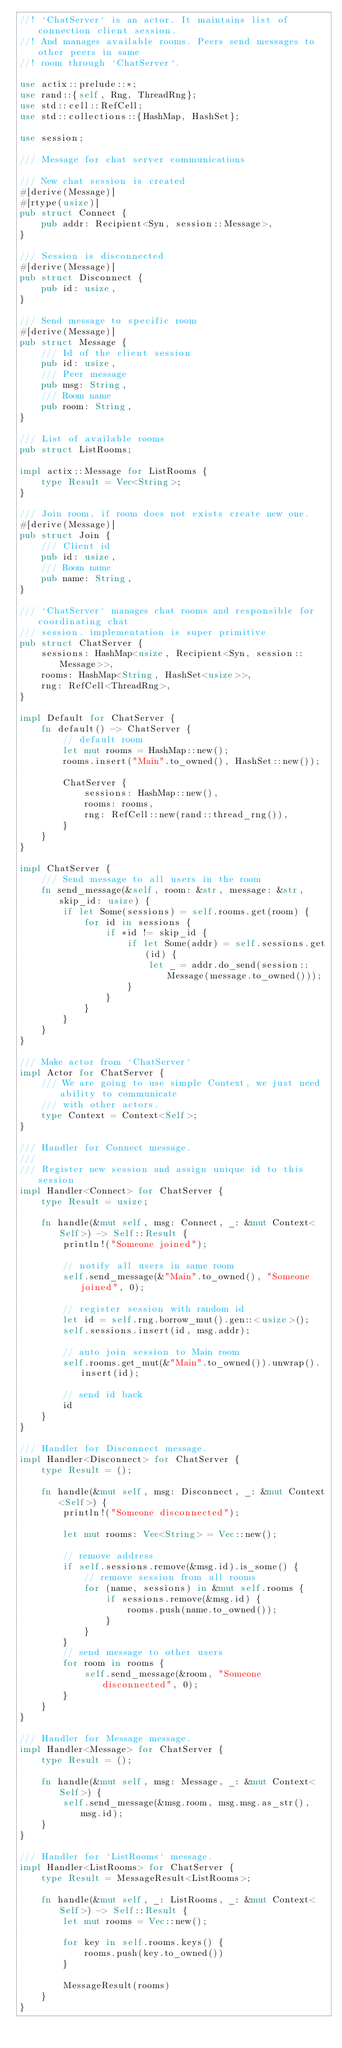<code> <loc_0><loc_0><loc_500><loc_500><_Rust_>//! `ChatServer` is an actor. It maintains list of connection client session.
//! And manages available rooms. Peers send messages to other peers in same
//! room through `ChatServer`.

use actix::prelude::*;
use rand::{self, Rng, ThreadRng};
use std::cell::RefCell;
use std::collections::{HashMap, HashSet};

use session;

/// Message for chat server communications

/// New chat session is created
#[derive(Message)]
#[rtype(usize)]
pub struct Connect {
    pub addr: Recipient<Syn, session::Message>,
}

/// Session is disconnected
#[derive(Message)]
pub struct Disconnect {
    pub id: usize,
}

/// Send message to specific room
#[derive(Message)]
pub struct Message {
    /// Id of the client session
    pub id: usize,
    /// Peer message
    pub msg: String,
    /// Room name
    pub room: String,
}

/// List of available rooms
pub struct ListRooms;

impl actix::Message for ListRooms {
    type Result = Vec<String>;
}

/// Join room, if room does not exists create new one.
#[derive(Message)]
pub struct Join {
    /// Client id
    pub id: usize,
    /// Room name
    pub name: String,
}

/// `ChatServer` manages chat rooms and responsible for coordinating chat
/// session. implementation is super primitive
pub struct ChatServer {
    sessions: HashMap<usize, Recipient<Syn, session::Message>>,
    rooms: HashMap<String, HashSet<usize>>,
    rng: RefCell<ThreadRng>,
}

impl Default for ChatServer {
    fn default() -> ChatServer {
        // default room
        let mut rooms = HashMap::new();
        rooms.insert("Main".to_owned(), HashSet::new());

        ChatServer {
            sessions: HashMap::new(),
            rooms: rooms,
            rng: RefCell::new(rand::thread_rng()),
        }
    }
}

impl ChatServer {
    /// Send message to all users in the room
    fn send_message(&self, room: &str, message: &str, skip_id: usize) {
        if let Some(sessions) = self.rooms.get(room) {
            for id in sessions {
                if *id != skip_id {
                    if let Some(addr) = self.sessions.get(id) {
                        let _ = addr.do_send(session::Message(message.to_owned()));
                    }
                }
            }
        }
    }
}

/// Make actor from `ChatServer`
impl Actor for ChatServer {
    /// We are going to use simple Context, we just need ability to communicate
    /// with other actors.
    type Context = Context<Self>;
}

/// Handler for Connect message.
///
/// Register new session and assign unique id to this session
impl Handler<Connect> for ChatServer {
    type Result = usize;

    fn handle(&mut self, msg: Connect, _: &mut Context<Self>) -> Self::Result {
        println!("Someone joined");

        // notify all users in same room
        self.send_message(&"Main".to_owned(), "Someone joined", 0);

        // register session with random id
        let id = self.rng.borrow_mut().gen::<usize>();
        self.sessions.insert(id, msg.addr);

        // auto join session to Main room
        self.rooms.get_mut(&"Main".to_owned()).unwrap().insert(id);

        // send id back
        id
    }
}

/// Handler for Disconnect message.
impl Handler<Disconnect> for ChatServer {
    type Result = ();

    fn handle(&mut self, msg: Disconnect, _: &mut Context<Self>) {
        println!("Someone disconnected");

        let mut rooms: Vec<String> = Vec::new();

        // remove address
        if self.sessions.remove(&msg.id).is_some() {
            // remove session from all rooms
            for (name, sessions) in &mut self.rooms {
                if sessions.remove(&msg.id) {
                    rooms.push(name.to_owned());
                }
            }
        }
        // send message to other users
        for room in rooms {
            self.send_message(&room, "Someone disconnected", 0);
        }
    }
}

/// Handler for Message message.
impl Handler<Message> for ChatServer {
    type Result = ();

    fn handle(&mut self, msg: Message, _: &mut Context<Self>) {
        self.send_message(&msg.room, msg.msg.as_str(), msg.id);
    }
}

/// Handler for `ListRooms` message.
impl Handler<ListRooms> for ChatServer {
    type Result = MessageResult<ListRooms>;

    fn handle(&mut self, _: ListRooms, _: &mut Context<Self>) -> Self::Result {
        let mut rooms = Vec::new();

        for key in self.rooms.keys() {
            rooms.push(key.to_owned())
        }

        MessageResult(rooms)
    }
}
</code> 